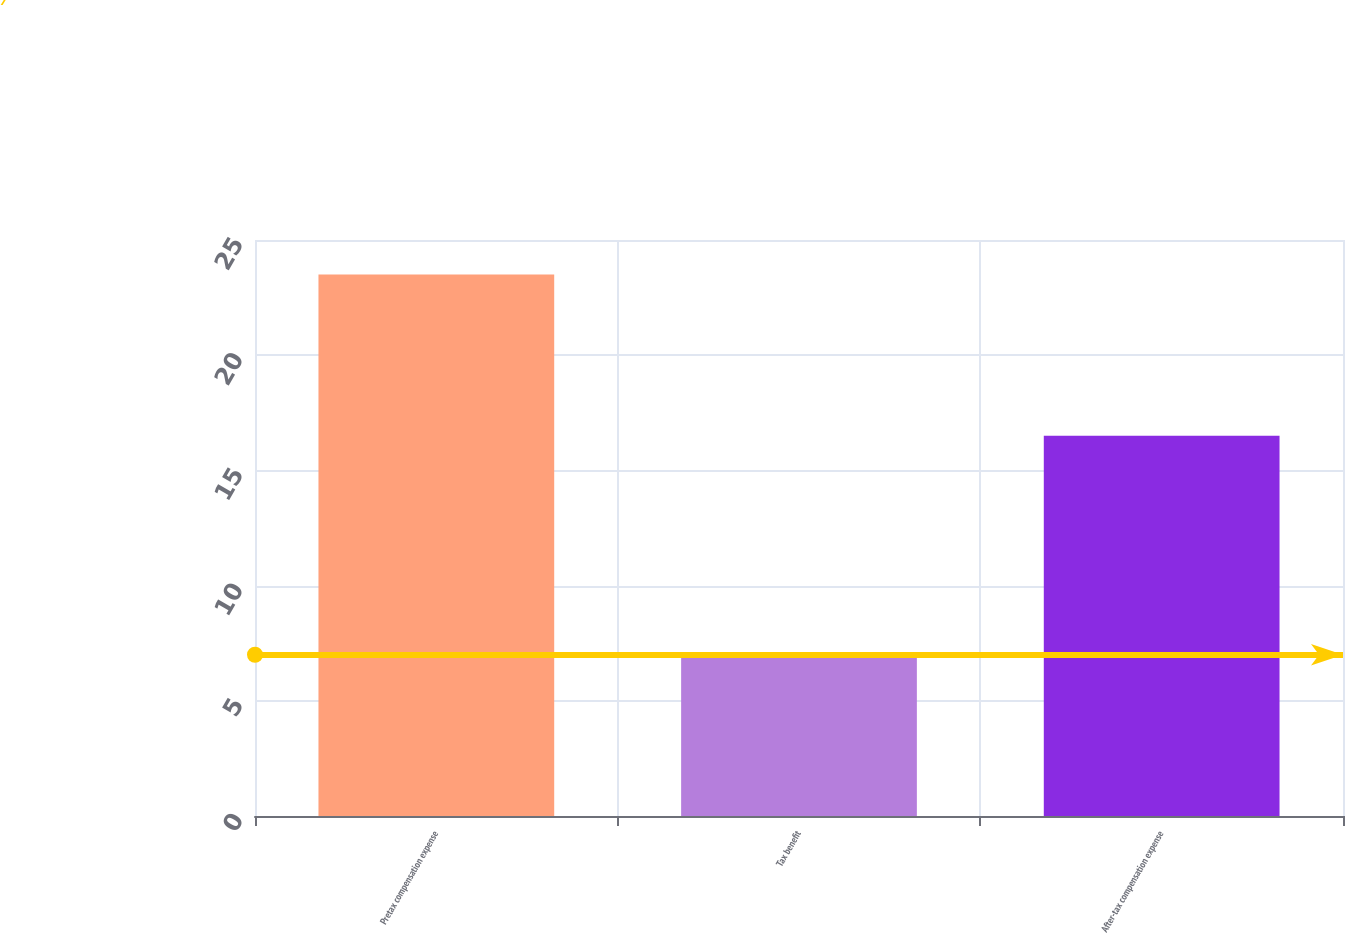<chart> <loc_0><loc_0><loc_500><loc_500><bar_chart><fcel>Pretax compensation expense<fcel>Tax benefit<fcel>After-tax compensation expense<nl><fcel>23.5<fcel>7<fcel>16.5<nl></chart> 